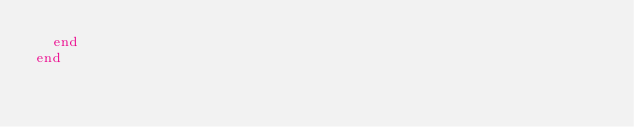<code> <loc_0><loc_0><loc_500><loc_500><_Ruby_>  end
end
</code> 